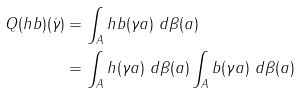<formula> <loc_0><loc_0><loc_500><loc_500>Q ( h b ) ( \dot { \gamma } ) & = \int _ { A } h b ( \gamma a ) \ d \beta ( a ) \\ & = \int _ { A } h ( \gamma a ) \ d \beta ( a ) \int _ { A } b ( \gamma a ) \ d \beta ( a )</formula> 